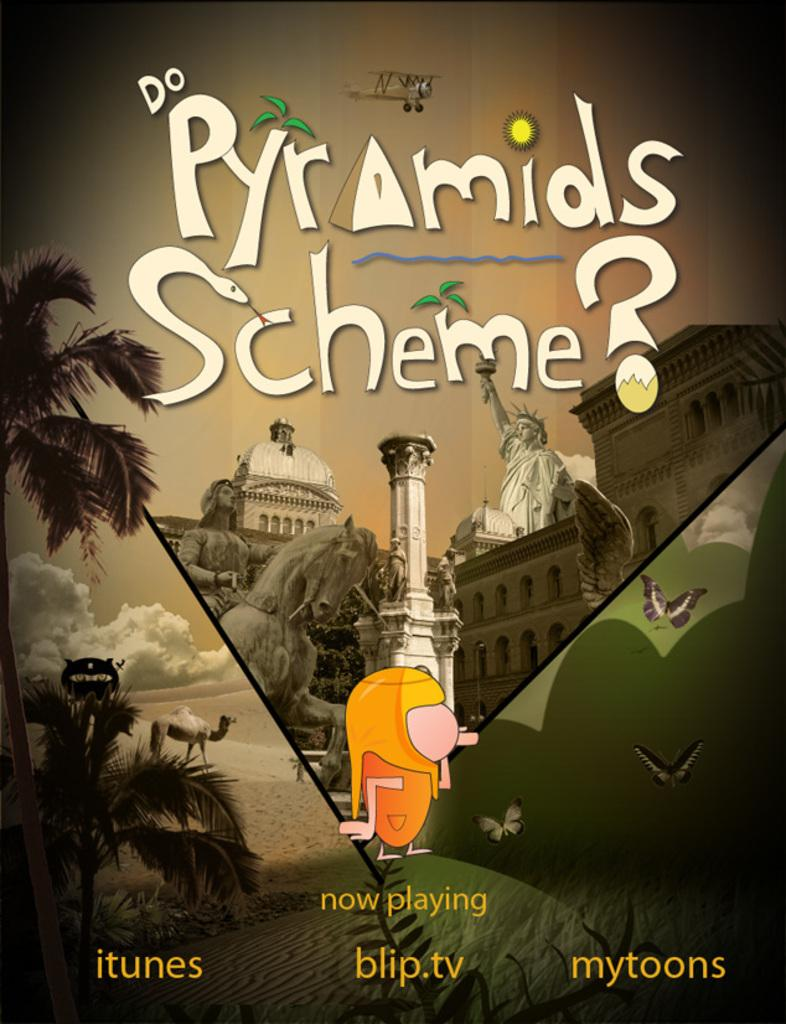<image>
Render a clear and concise summary of the photo. the poster that says now playing on it 